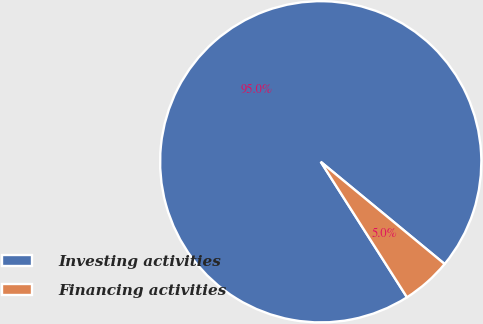Convert chart. <chart><loc_0><loc_0><loc_500><loc_500><pie_chart><fcel>Investing activities<fcel>Financing activities<nl><fcel>95.0%<fcel>5.0%<nl></chart> 